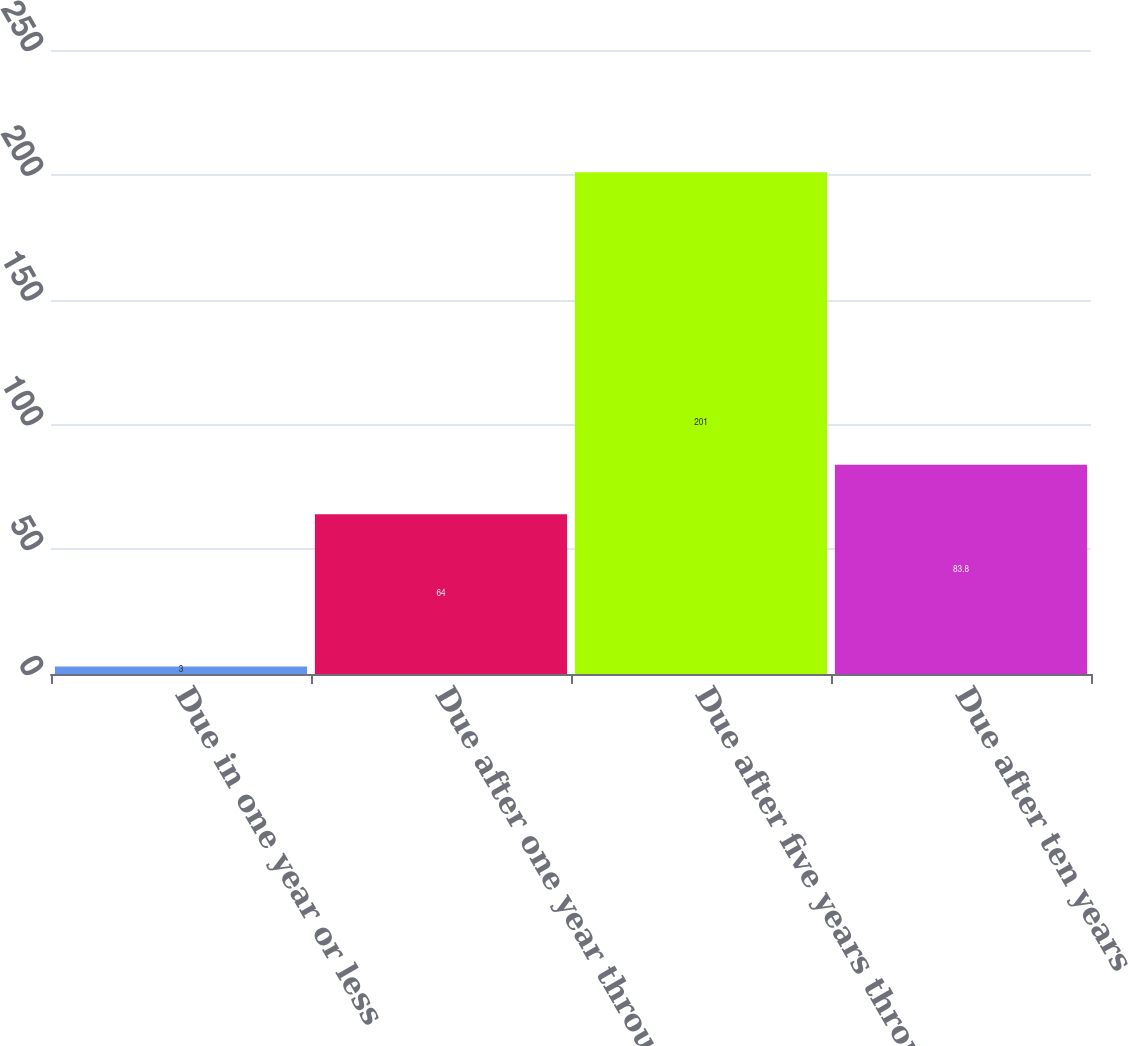Convert chart. <chart><loc_0><loc_0><loc_500><loc_500><bar_chart><fcel>Due in one year or less<fcel>Due after one year through<fcel>Due after five years through<fcel>Due after ten years<nl><fcel>3<fcel>64<fcel>201<fcel>83.8<nl></chart> 